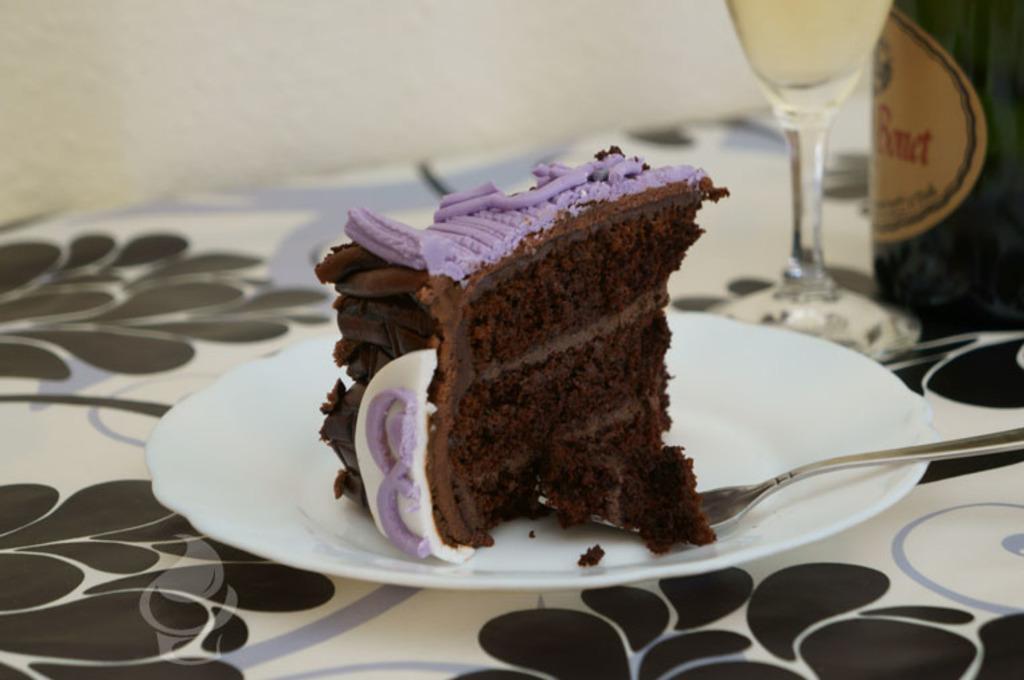How would you summarize this image in a sentence or two? In this image there is a plate on a surface. There is a piece of a cake on the plate. Beside the cake there is a fork on the plate. To the right there is a bottle on the surface. There is a label with text on the bottle. Beside the bottle there is a glass. At the top there is a wall. 